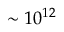<formula> <loc_0><loc_0><loc_500><loc_500>\sim 1 0 ^ { 1 2 }</formula> 